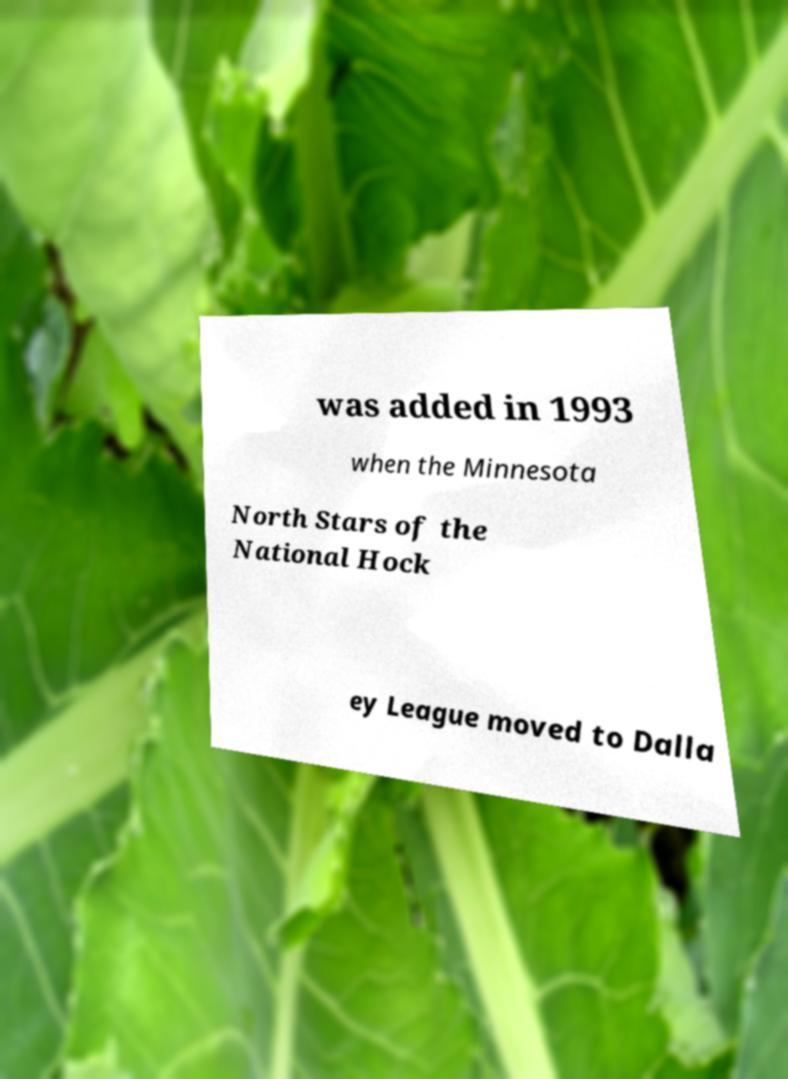Could you assist in decoding the text presented in this image and type it out clearly? was added in 1993 when the Minnesota North Stars of the National Hock ey League moved to Dalla 